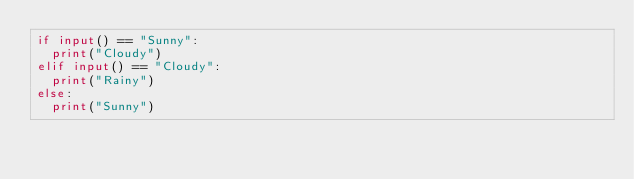Convert code to text. <code><loc_0><loc_0><loc_500><loc_500><_Python_>if input() == "Sunny":
  print("Cloudy")
elif input() == "Cloudy":
  print("Rainy")
else:
  print("Sunny")
</code> 